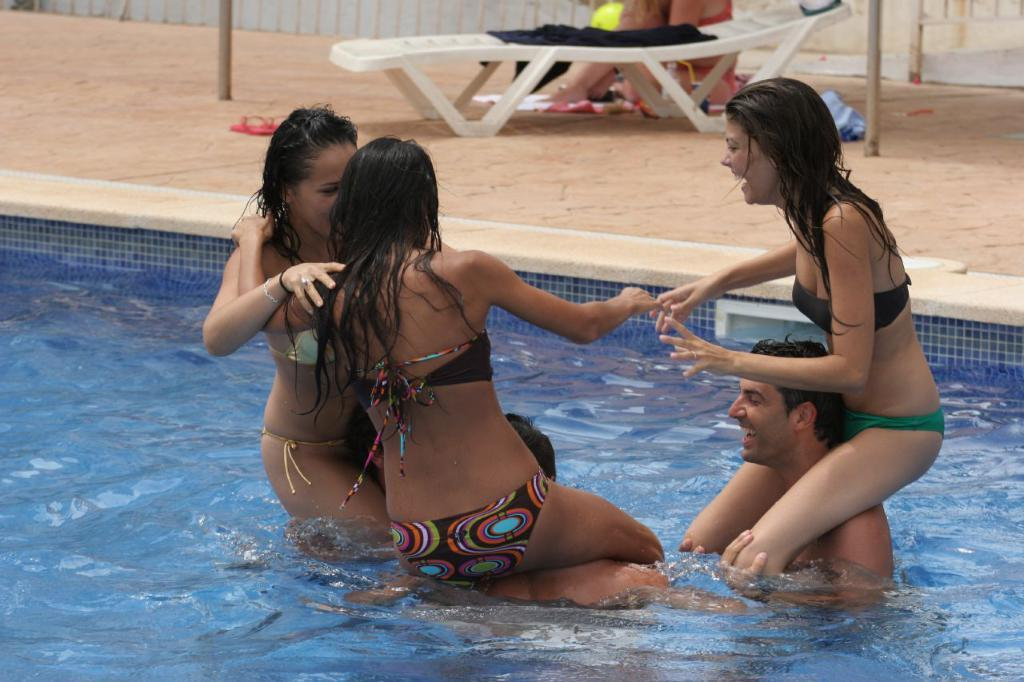What activity are the people in the image engaged in? The group of people in the image are in a swimming pool. What can be seen in the background of the image? There is a chair in the background with some clothes on it. What else is visible in the image besides the people and the chair? A pair of footwear is visible in the image. What type of approval is being given in the image? There is no indication of approval in the image. 